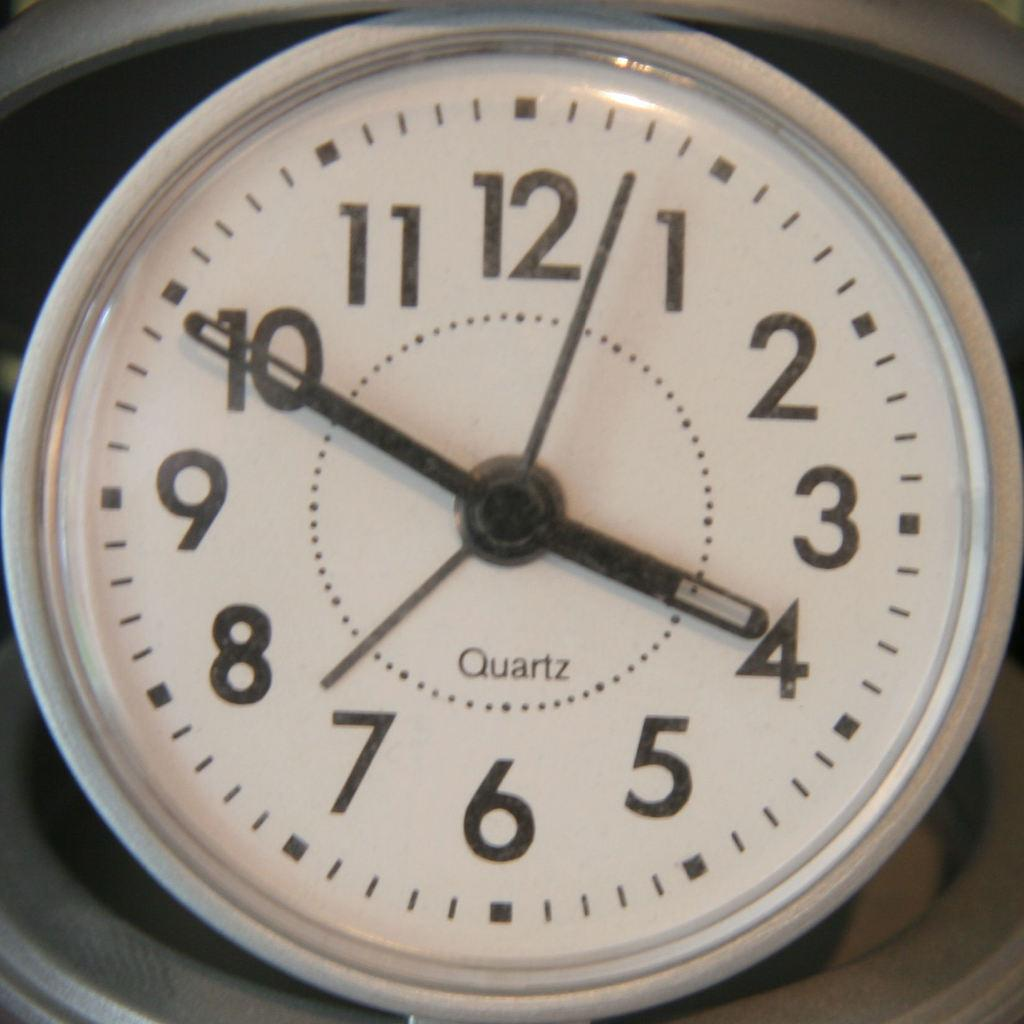Provide a one-sentence caption for the provided image. A quartz clock that shows a time of 3:50. 